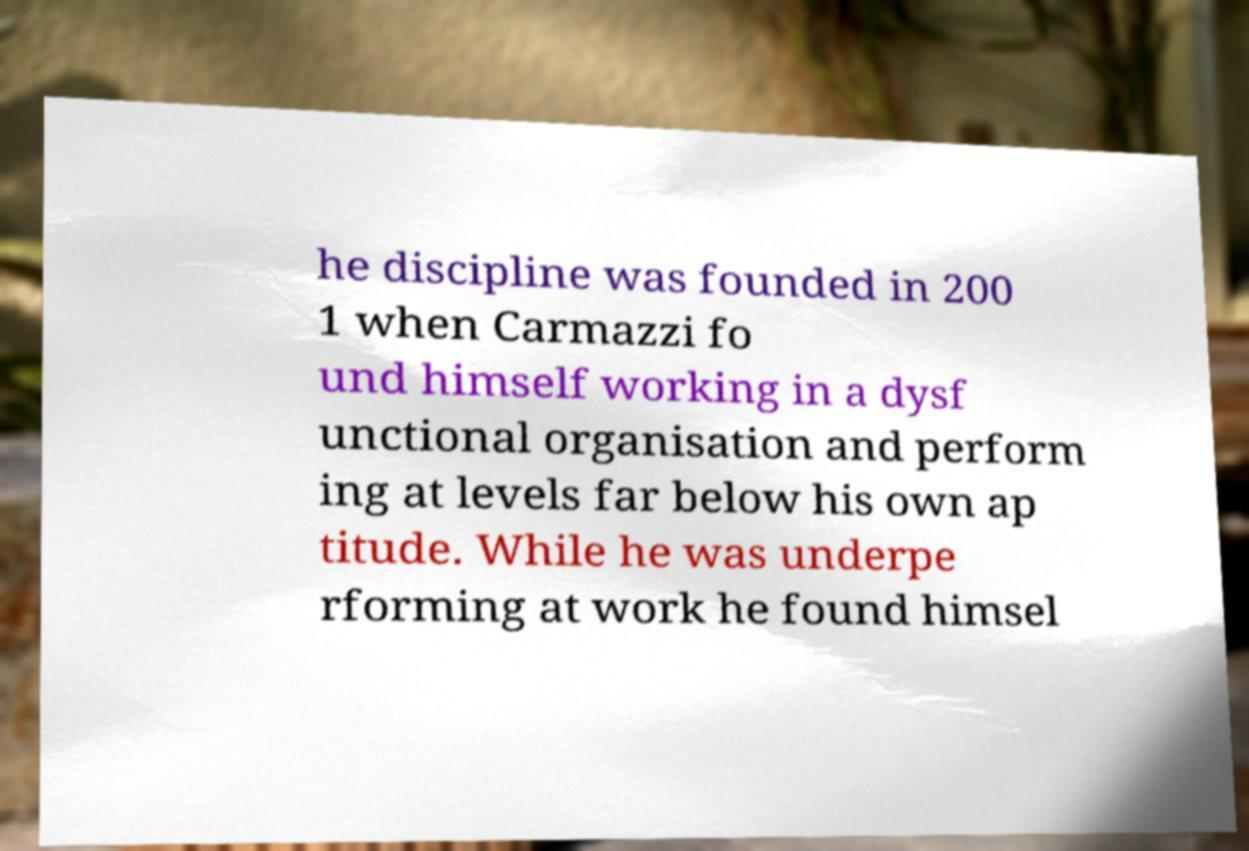What messages or text are displayed in this image? I need them in a readable, typed format. he discipline was founded in 200 1 when Carmazzi fo und himself working in a dysf unctional organisation and perform ing at levels far below his own ap titude. While he was underpe rforming at work he found himsel 